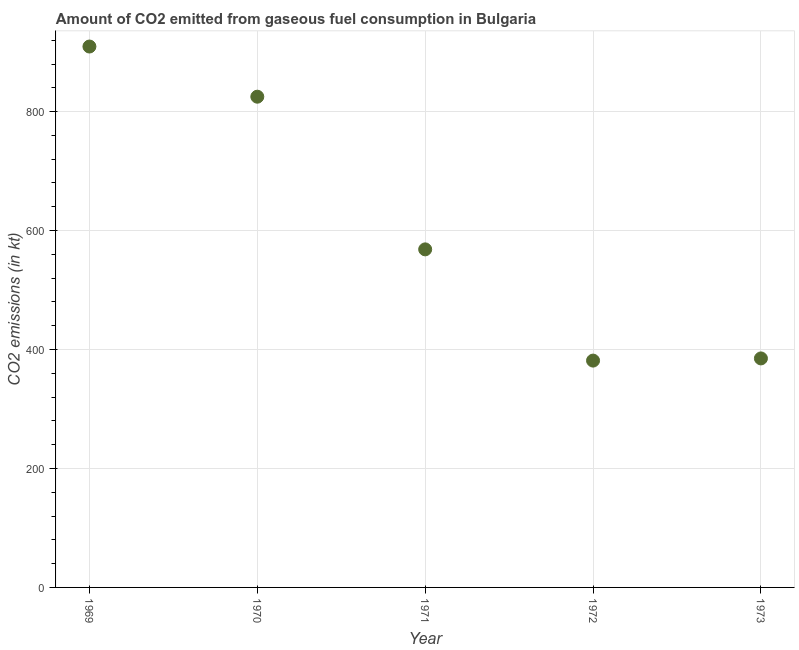What is the co2 emissions from gaseous fuel consumption in 1970?
Offer a very short reply. 825.08. Across all years, what is the maximum co2 emissions from gaseous fuel consumption?
Provide a succinct answer. 909.42. Across all years, what is the minimum co2 emissions from gaseous fuel consumption?
Your response must be concise. 381.37. In which year was the co2 emissions from gaseous fuel consumption maximum?
Offer a very short reply. 1969. What is the sum of the co2 emissions from gaseous fuel consumption?
Make the answer very short. 3069.28. What is the difference between the co2 emissions from gaseous fuel consumption in 1971 and 1972?
Your response must be concise. 187.02. What is the average co2 emissions from gaseous fuel consumption per year?
Provide a succinct answer. 613.86. What is the median co2 emissions from gaseous fuel consumption?
Your answer should be very brief. 568.38. Do a majority of the years between 1969 and 1972 (inclusive) have co2 emissions from gaseous fuel consumption greater than 760 kt?
Give a very brief answer. No. What is the difference between the highest and the second highest co2 emissions from gaseous fuel consumption?
Provide a short and direct response. 84.34. What is the difference between the highest and the lowest co2 emissions from gaseous fuel consumption?
Give a very brief answer. 528.05. In how many years, is the co2 emissions from gaseous fuel consumption greater than the average co2 emissions from gaseous fuel consumption taken over all years?
Offer a very short reply. 2. How many years are there in the graph?
Provide a succinct answer. 5. Are the values on the major ticks of Y-axis written in scientific E-notation?
Offer a terse response. No. Does the graph contain grids?
Give a very brief answer. Yes. What is the title of the graph?
Your response must be concise. Amount of CO2 emitted from gaseous fuel consumption in Bulgaria. What is the label or title of the Y-axis?
Your answer should be very brief. CO2 emissions (in kt). What is the CO2 emissions (in kt) in 1969?
Your answer should be very brief. 909.42. What is the CO2 emissions (in kt) in 1970?
Ensure brevity in your answer.  825.08. What is the CO2 emissions (in kt) in 1971?
Your answer should be very brief. 568.38. What is the CO2 emissions (in kt) in 1972?
Keep it short and to the point. 381.37. What is the CO2 emissions (in kt) in 1973?
Provide a short and direct response. 385.04. What is the difference between the CO2 emissions (in kt) in 1969 and 1970?
Ensure brevity in your answer.  84.34. What is the difference between the CO2 emissions (in kt) in 1969 and 1971?
Your answer should be very brief. 341.03. What is the difference between the CO2 emissions (in kt) in 1969 and 1972?
Make the answer very short. 528.05. What is the difference between the CO2 emissions (in kt) in 1969 and 1973?
Make the answer very short. 524.38. What is the difference between the CO2 emissions (in kt) in 1970 and 1971?
Provide a succinct answer. 256.69. What is the difference between the CO2 emissions (in kt) in 1970 and 1972?
Offer a very short reply. 443.71. What is the difference between the CO2 emissions (in kt) in 1970 and 1973?
Provide a short and direct response. 440.04. What is the difference between the CO2 emissions (in kt) in 1971 and 1972?
Offer a terse response. 187.02. What is the difference between the CO2 emissions (in kt) in 1971 and 1973?
Provide a short and direct response. 183.35. What is the difference between the CO2 emissions (in kt) in 1972 and 1973?
Keep it short and to the point. -3.67. What is the ratio of the CO2 emissions (in kt) in 1969 to that in 1970?
Your answer should be very brief. 1.1. What is the ratio of the CO2 emissions (in kt) in 1969 to that in 1971?
Make the answer very short. 1.6. What is the ratio of the CO2 emissions (in kt) in 1969 to that in 1972?
Provide a succinct answer. 2.38. What is the ratio of the CO2 emissions (in kt) in 1969 to that in 1973?
Your answer should be compact. 2.36. What is the ratio of the CO2 emissions (in kt) in 1970 to that in 1971?
Keep it short and to the point. 1.45. What is the ratio of the CO2 emissions (in kt) in 1970 to that in 1972?
Make the answer very short. 2.16. What is the ratio of the CO2 emissions (in kt) in 1970 to that in 1973?
Provide a short and direct response. 2.14. What is the ratio of the CO2 emissions (in kt) in 1971 to that in 1972?
Provide a short and direct response. 1.49. What is the ratio of the CO2 emissions (in kt) in 1971 to that in 1973?
Make the answer very short. 1.48. 